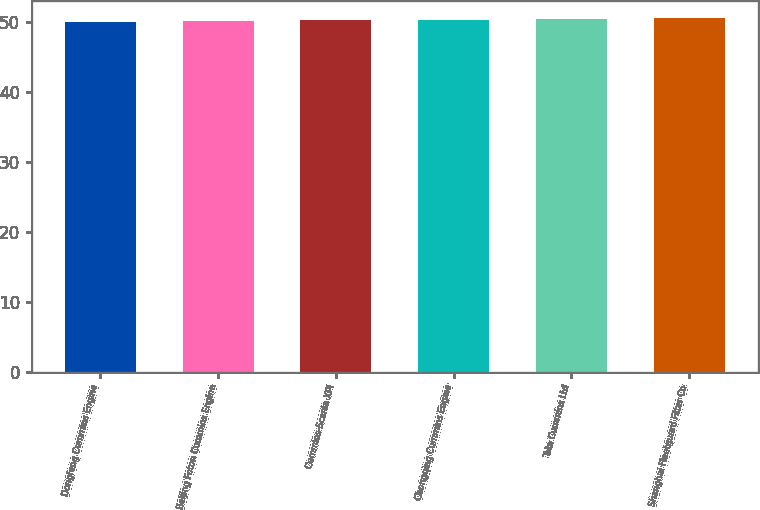Convert chart. <chart><loc_0><loc_0><loc_500><loc_500><bar_chart><fcel>Dongfeng Cummins Engine<fcel>Beijing Foton Cummins Engine<fcel>Cummins-Scania XPI<fcel>Chongqing Cummins Engine<fcel>Tata Cummins Ltd<fcel>Shanghai Fleetguard Filter Co<nl><fcel>50<fcel>50.1<fcel>50.2<fcel>50.3<fcel>50.4<fcel>50.5<nl></chart> 